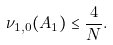Convert formula to latex. <formula><loc_0><loc_0><loc_500><loc_500>\nu _ { 1 , 0 } ( A _ { 1 } ) \leq \frac { 4 } { N } .</formula> 